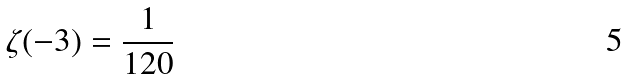<formula> <loc_0><loc_0><loc_500><loc_500>\zeta ( - 3 ) = { \frac { 1 } { 1 2 0 } }</formula> 